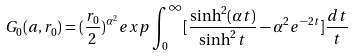Convert formula to latex. <formula><loc_0><loc_0><loc_500><loc_500>G _ { 0 } ( a , r _ { 0 } ) = ( \frac { r _ { 0 } } 2 ) ^ { \alpha ^ { 2 } } e x p \int _ { 0 } ^ { \infty } [ \frac { \sinh ^ { 2 } ( \alpha t ) } { \sinh ^ { 2 } t } - \alpha ^ { 2 } e ^ { - 2 t } ] \frac { d t } t</formula> 